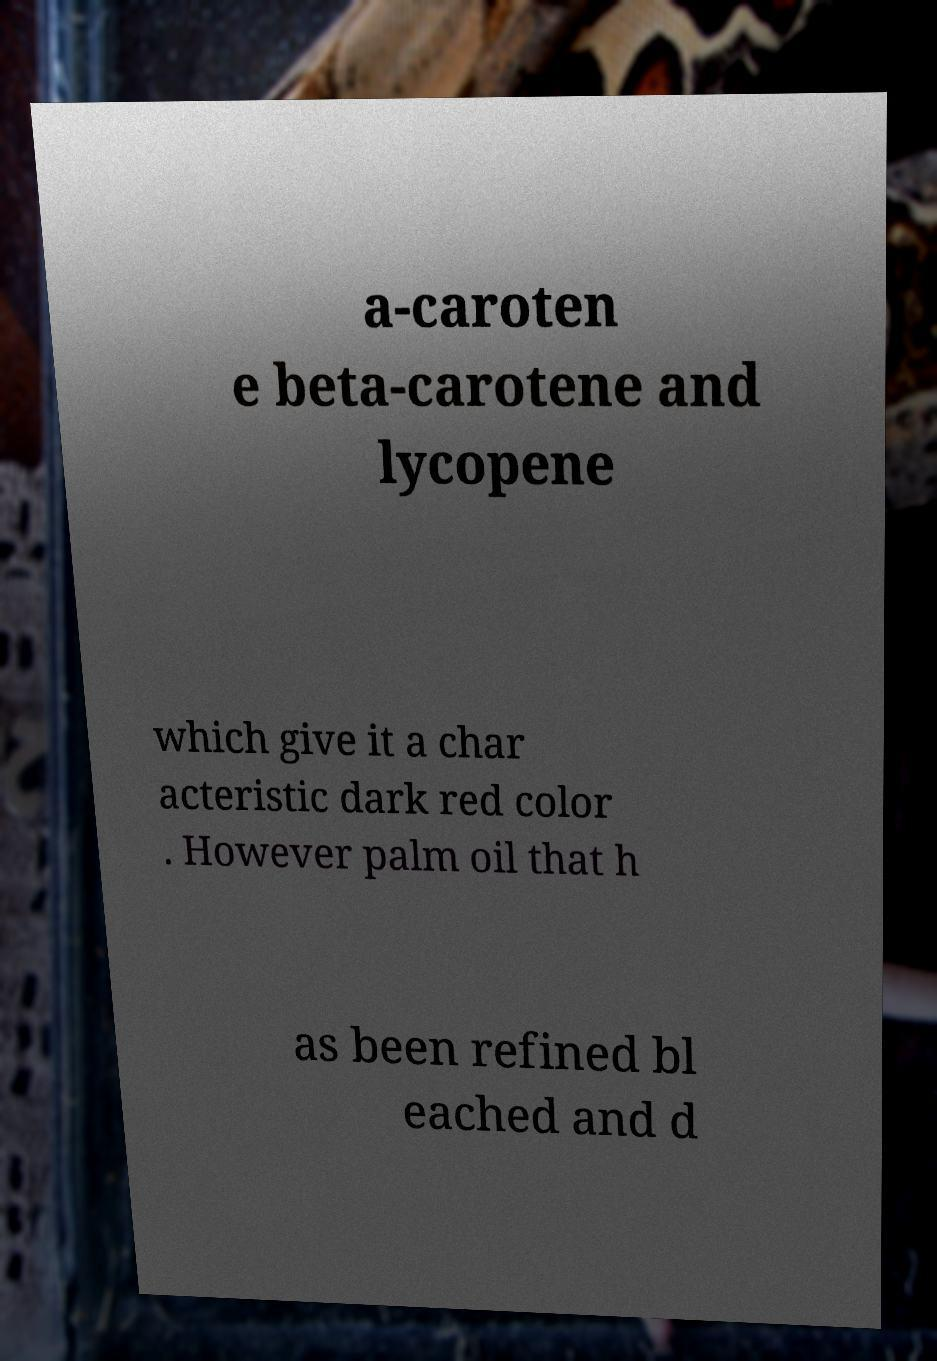For documentation purposes, I need the text within this image transcribed. Could you provide that? a-caroten e beta-carotene and lycopene which give it a char acteristic dark red color . However palm oil that h as been refined bl eached and d 